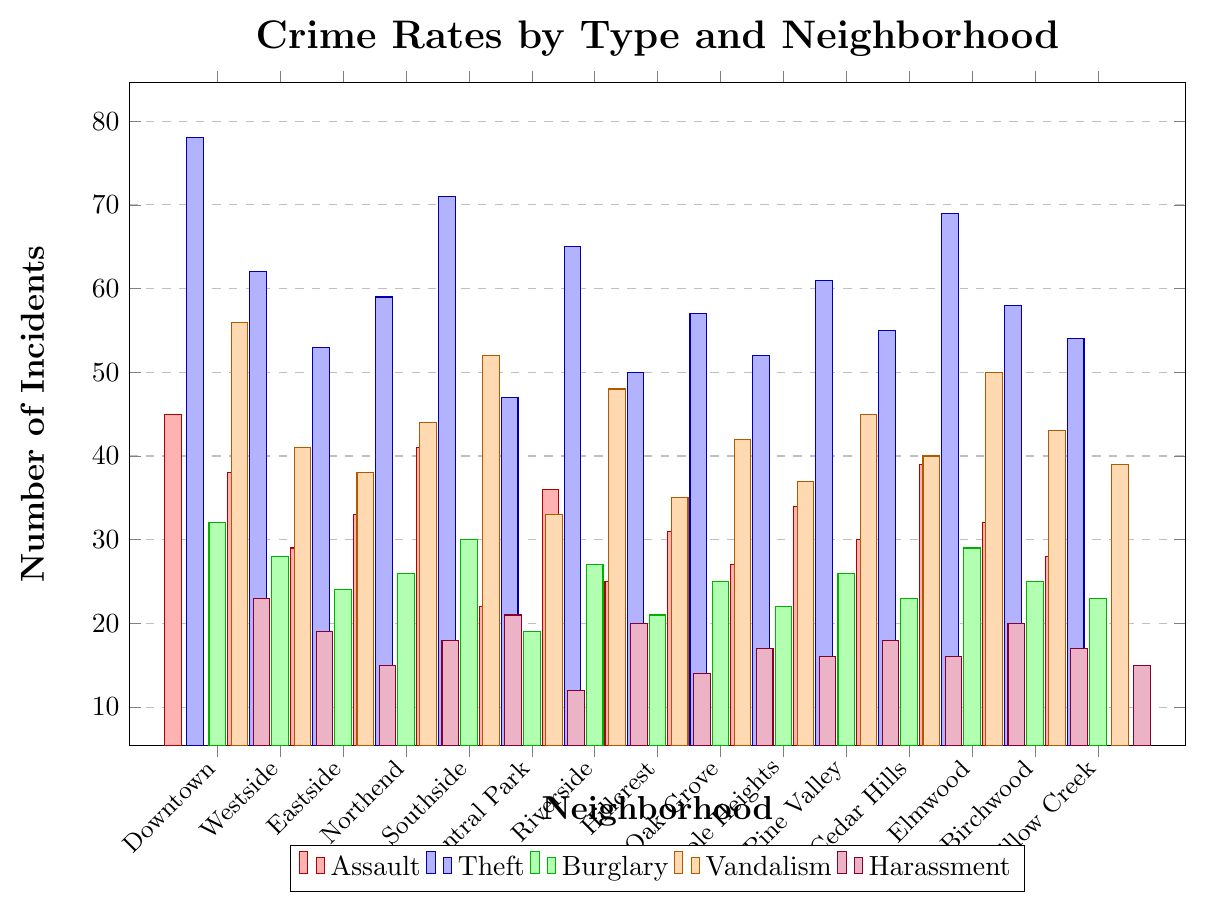Which neighborhood has the highest total crime incidents? To find the neighborhood with the highest total crime incidents, sum up the incidents of all types for each neighborhood and compare. Downtown has the highest total with 45 (Assault) + 78 (Theft) + 32 (Burglary) + 56 (Vandalism) + 23 (Harassment) = 234.
Answer: Downtown What is the difference in theft incidents between Riverside and Central Park? Refer to the figure and check the values for theft incidents for both neighborhoods. Riverside has 65 theft incidents and Central Park has 47. The difference is 65 - 47 = 18.
Answer: 18 Which neighborhood has the lowest number of burglary incidents? Scan through the burglary incidents bars and find the neighborhood with the shortest bar. Central Park has the lowest number of burglary incidents with 19.
Answer: Central Park Compare the number of vandalism incidents in Northend and Willow Creek. Which neighborhood has more incidents and by how many? Check the vandalism incidents for both neighborhoods. Northend has 44 and Willow Creek has 39. Northend has 44 - 39 = 5 more incidents.
Answer: Northend, 5 Which has more harassment incidents, Oak Grove or Cedar Hills? Look at the harassment bars for Oak Grove and Cedar Hills. Oak Grove has 17 harassment incidents, and Cedar Hills has 16. Oak Grove has more harassment incidents.
Answer: Oak Grove What is the average number of vandalism incidents across all neighborhoods? Sum the vandalism incidents for all neighborhoods and divide by the number of neighborhoods (15). The total number of vandalism incidents is 674, so the average is 674 / 15 = approximately 44.93.
Answer: approximately 44.93 Among Downtown, Westside, and Eastside, which has the highest number of assault incidents? Compare the height of the assault bars for Downtown, Westside, and Eastside. Downtown has the highest number with 45 assault incidents.
Answer: Downtown How many more theft incidents are there in Elmwood compared to Westside? Check the theft incidents for Elmwood and Westside. Elmwood has 69 theft incidents and Westside has 62. The difference is 69 - 62 = 7.
Answer: 7 What is the total number of harassment incidents in the Southside and Cedar Hills neighborhoods combined? Refer to the figure and sum the harassment incidents for these two neighborhoods. Southside has 21 and Cedar Hills has 16. The total is 21 + 16 = 37.
Answer: 37 